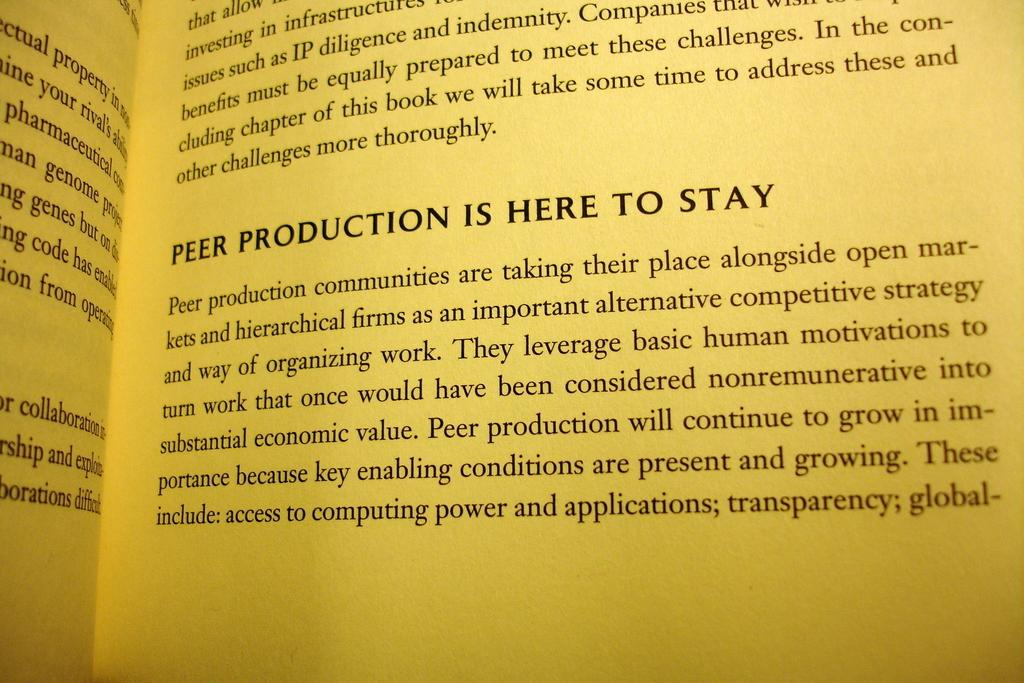<image>
Describe the image concisely. A page from a book with a section titled Peer Production is here to stay. 